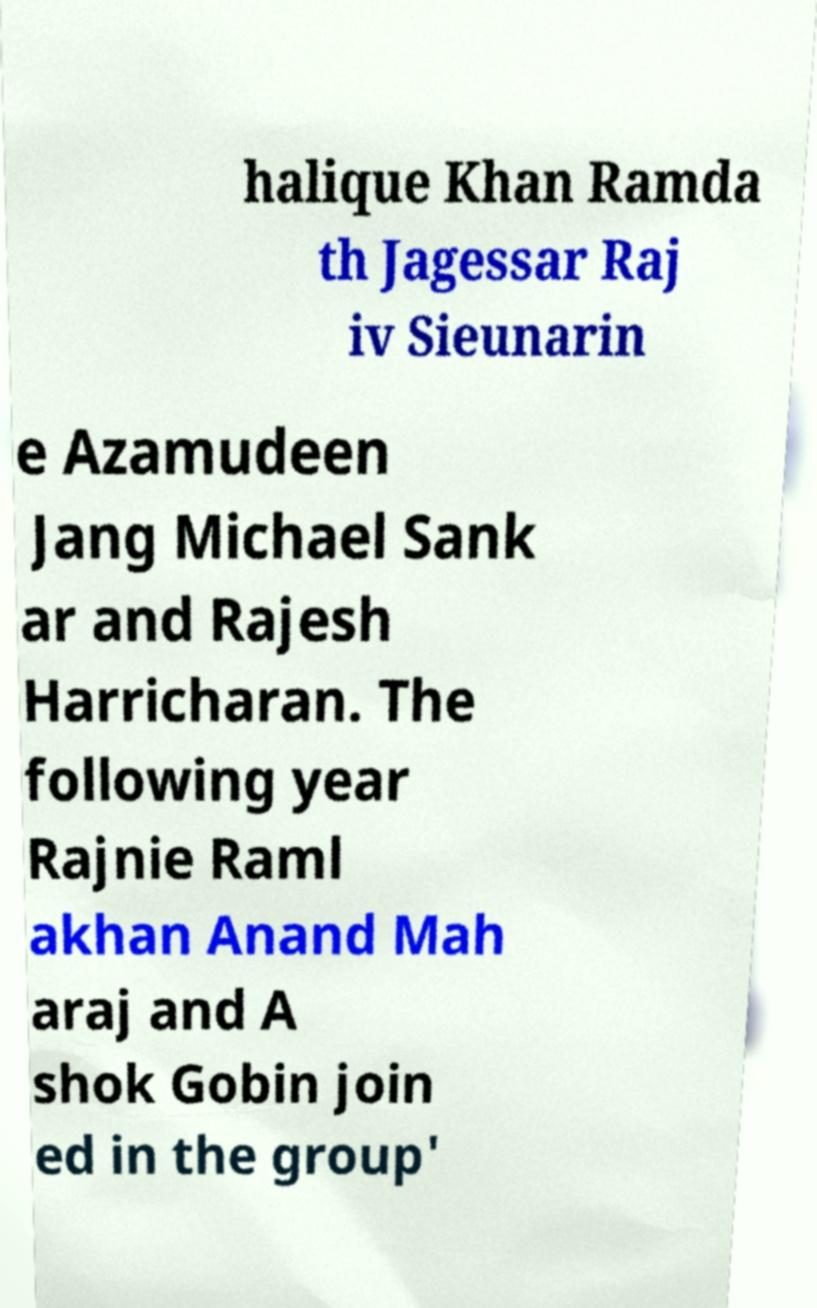For documentation purposes, I need the text within this image transcribed. Could you provide that? halique Khan Ramda th Jagessar Raj iv Sieunarin e Azamudeen Jang Michael Sank ar and Rajesh Harricharan. The following year Rajnie Raml akhan Anand Mah araj and A shok Gobin join ed in the group' 